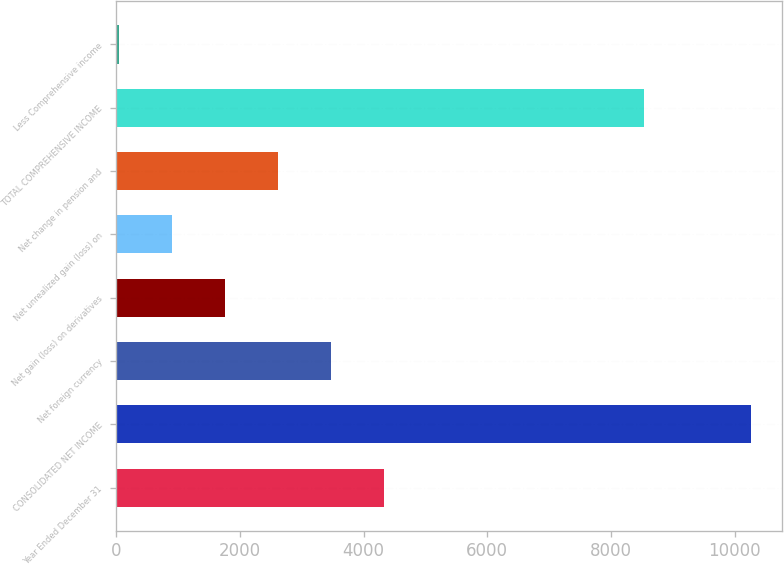Convert chart. <chart><loc_0><loc_0><loc_500><loc_500><bar_chart><fcel>Year Ended December 31<fcel>CONSOLIDATED NET INCOME<fcel>Net foreign currency<fcel>Net gain (loss) on derivatives<fcel>Net unrealized gain (loss) on<fcel>Net change in pension and<fcel>TOTAL COMPREHENSIVE INCOME<fcel>Less Comprehensive income<nl><fcel>4332.5<fcel>10254.4<fcel>3473.8<fcel>1756.4<fcel>897.7<fcel>2615.1<fcel>8537<fcel>39<nl></chart> 